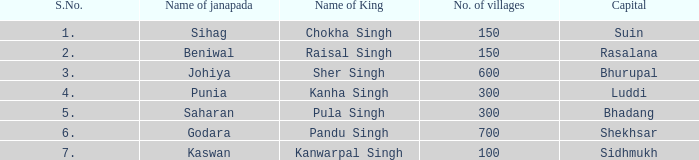What capital has an S.Number under 7, and a Name of janapada of Punia? Luddi. 